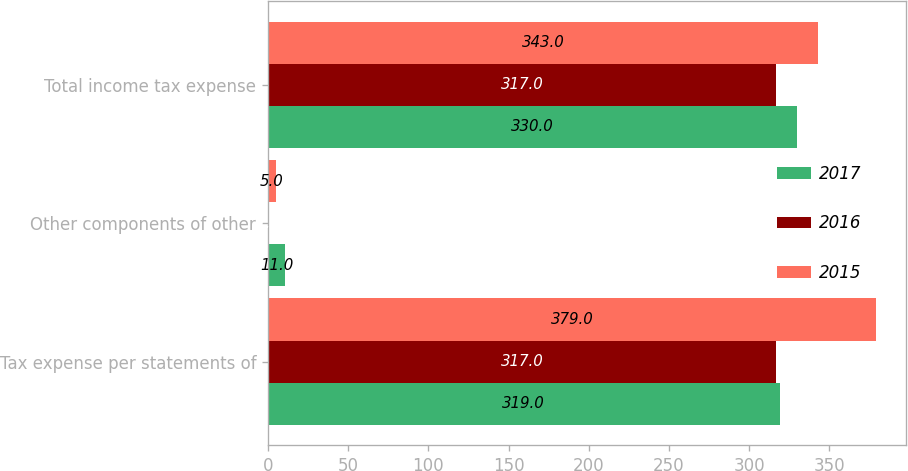Convert chart to OTSL. <chart><loc_0><loc_0><loc_500><loc_500><stacked_bar_chart><ecel><fcel>Tax expense per statements of<fcel>Other components of other<fcel>Total income tax expense<nl><fcel>2017<fcel>319<fcel>11<fcel>330<nl><fcel>2016<fcel>317<fcel>1<fcel>317<nl><fcel>2015<fcel>379<fcel>5<fcel>343<nl></chart> 